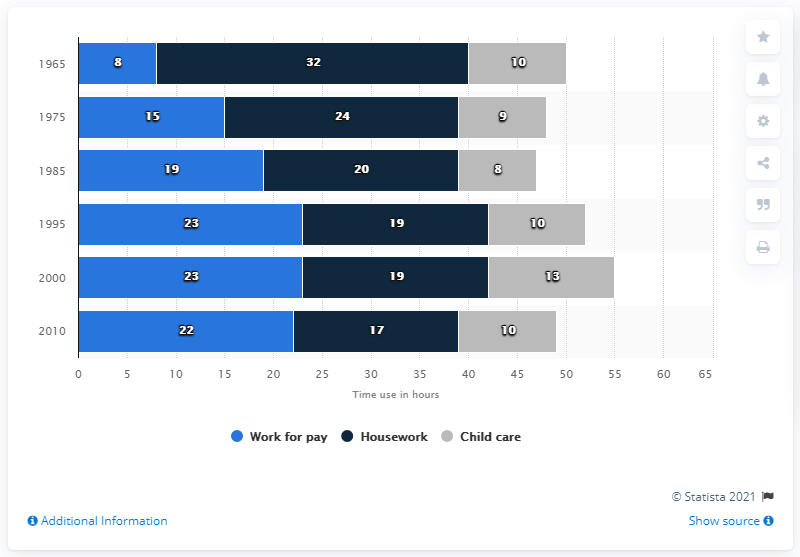Identify some key points in this picture. In the United States, mothers typically dedicate 17 hours per week to household chores. 